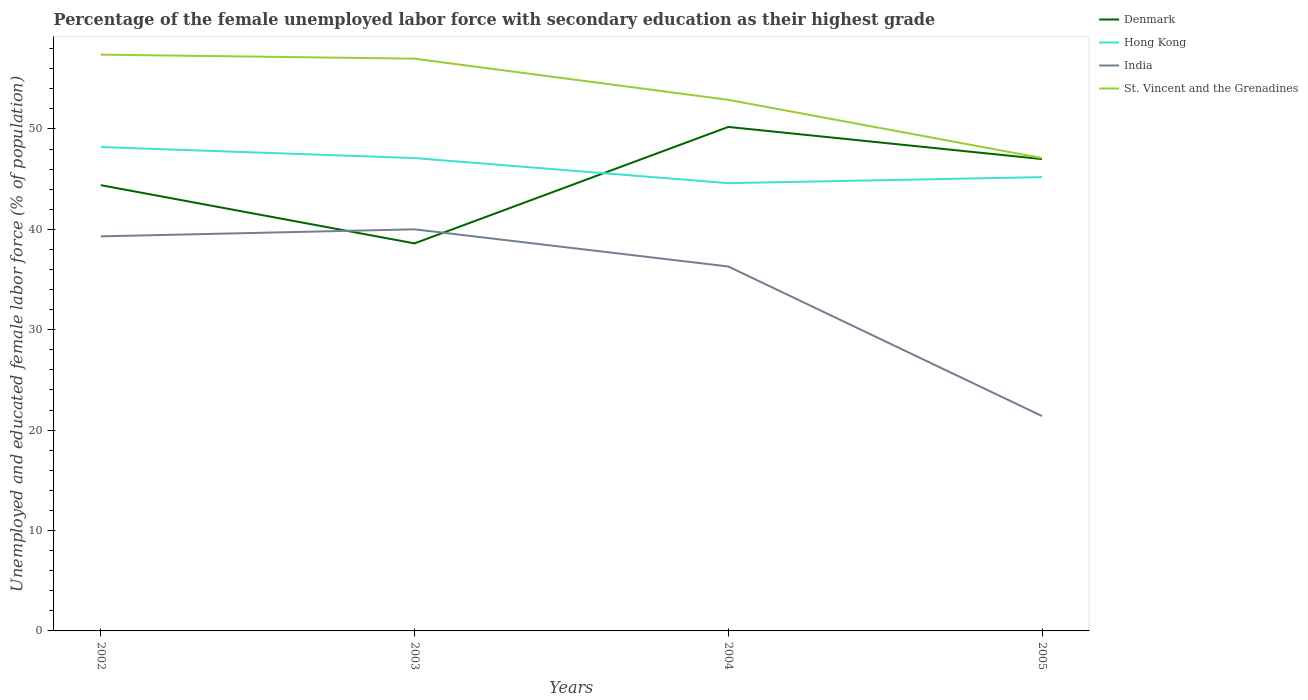Does the line corresponding to St. Vincent and the Grenadines intersect with the line corresponding to Denmark?
Your response must be concise. No. Across all years, what is the maximum percentage of the unemployed female labor force with secondary education in Hong Kong?
Give a very brief answer. 44.6. In which year was the percentage of the unemployed female labor force with secondary education in Hong Kong maximum?
Offer a terse response. 2004. What is the total percentage of the unemployed female labor force with secondary education in India in the graph?
Offer a terse response. 3.7. What is the difference between the highest and the second highest percentage of the unemployed female labor force with secondary education in St. Vincent and the Grenadines?
Offer a terse response. 10.3. What is the difference between the highest and the lowest percentage of the unemployed female labor force with secondary education in India?
Your answer should be compact. 3. How many lines are there?
Provide a succinct answer. 4. What is the difference between two consecutive major ticks on the Y-axis?
Offer a terse response. 10. Does the graph contain any zero values?
Make the answer very short. No. Does the graph contain grids?
Provide a succinct answer. No. Where does the legend appear in the graph?
Make the answer very short. Top right. How are the legend labels stacked?
Provide a succinct answer. Vertical. What is the title of the graph?
Your answer should be very brief. Percentage of the female unemployed labor force with secondary education as their highest grade. What is the label or title of the Y-axis?
Ensure brevity in your answer.  Unemployed and educated female labor force (% of population). What is the Unemployed and educated female labor force (% of population) in Denmark in 2002?
Your answer should be compact. 44.4. What is the Unemployed and educated female labor force (% of population) of Hong Kong in 2002?
Make the answer very short. 48.2. What is the Unemployed and educated female labor force (% of population) in India in 2002?
Offer a very short reply. 39.3. What is the Unemployed and educated female labor force (% of population) of St. Vincent and the Grenadines in 2002?
Keep it short and to the point. 57.4. What is the Unemployed and educated female labor force (% of population) of Denmark in 2003?
Make the answer very short. 38.6. What is the Unemployed and educated female labor force (% of population) of Hong Kong in 2003?
Offer a terse response. 47.1. What is the Unemployed and educated female labor force (% of population) of India in 2003?
Your answer should be compact. 40. What is the Unemployed and educated female labor force (% of population) of Denmark in 2004?
Make the answer very short. 50.2. What is the Unemployed and educated female labor force (% of population) in Hong Kong in 2004?
Provide a short and direct response. 44.6. What is the Unemployed and educated female labor force (% of population) of India in 2004?
Make the answer very short. 36.3. What is the Unemployed and educated female labor force (% of population) of St. Vincent and the Grenadines in 2004?
Ensure brevity in your answer.  52.9. What is the Unemployed and educated female labor force (% of population) in Denmark in 2005?
Provide a short and direct response. 47. What is the Unemployed and educated female labor force (% of population) of Hong Kong in 2005?
Provide a short and direct response. 45.2. What is the Unemployed and educated female labor force (% of population) in India in 2005?
Make the answer very short. 21.4. What is the Unemployed and educated female labor force (% of population) in St. Vincent and the Grenadines in 2005?
Offer a terse response. 47.1. Across all years, what is the maximum Unemployed and educated female labor force (% of population) of Denmark?
Give a very brief answer. 50.2. Across all years, what is the maximum Unemployed and educated female labor force (% of population) in Hong Kong?
Offer a terse response. 48.2. Across all years, what is the maximum Unemployed and educated female labor force (% of population) of St. Vincent and the Grenadines?
Provide a succinct answer. 57.4. Across all years, what is the minimum Unemployed and educated female labor force (% of population) in Denmark?
Make the answer very short. 38.6. Across all years, what is the minimum Unemployed and educated female labor force (% of population) in Hong Kong?
Provide a short and direct response. 44.6. Across all years, what is the minimum Unemployed and educated female labor force (% of population) in India?
Offer a very short reply. 21.4. Across all years, what is the minimum Unemployed and educated female labor force (% of population) in St. Vincent and the Grenadines?
Keep it short and to the point. 47.1. What is the total Unemployed and educated female labor force (% of population) in Denmark in the graph?
Provide a succinct answer. 180.2. What is the total Unemployed and educated female labor force (% of population) of Hong Kong in the graph?
Offer a terse response. 185.1. What is the total Unemployed and educated female labor force (% of population) in India in the graph?
Offer a terse response. 137. What is the total Unemployed and educated female labor force (% of population) of St. Vincent and the Grenadines in the graph?
Your answer should be compact. 214.4. What is the difference between the Unemployed and educated female labor force (% of population) in Hong Kong in 2002 and that in 2004?
Provide a short and direct response. 3.6. What is the difference between the Unemployed and educated female labor force (% of population) of St. Vincent and the Grenadines in 2002 and that in 2004?
Ensure brevity in your answer.  4.5. What is the difference between the Unemployed and educated female labor force (% of population) of Denmark in 2002 and that in 2005?
Provide a succinct answer. -2.6. What is the difference between the Unemployed and educated female labor force (% of population) of Hong Kong in 2002 and that in 2005?
Offer a terse response. 3. What is the difference between the Unemployed and educated female labor force (% of population) in St. Vincent and the Grenadines in 2002 and that in 2005?
Ensure brevity in your answer.  10.3. What is the difference between the Unemployed and educated female labor force (% of population) in Denmark in 2003 and that in 2004?
Your answer should be very brief. -11.6. What is the difference between the Unemployed and educated female labor force (% of population) in India in 2003 and that in 2004?
Offer a terse response. 3.7. What is the difference between the Unemployed and educated female labor force (% of population) in St. Vincent and the Grenadines in 2003 and that in 2005?
Offer a terse response. 9.9. What is the difference between the Unemployed and educated female labor force (% of population) in Denmark in 2004 and that in 2005?
Your answer should be compact. 3.2. What is the difference between the Unemployed and educated female labor force (% of population) of Hong Kong in 2004 and that in 2005?
Offer a very short reply. -0.6. What is the difference between the Unemployed and educated female labor force (% of population) in St. Vincent and the Grenadines in 2004 and that in 2005?
Ensure brevity in your answer.  5.8. What is the difference between the Unemployed and educated female labor force (% of population) of Denmark in 2002 and the Unemployed and educated female labor force (% of population) of Hong Kong in 2003?
Keep it short and to the point. -2.7. What is the difference between the Unemployed and educated female labor force (% of population) in Denmark in 2002 and the Unemployed and educated female labor force (% of population) in St. Vincent and the Grenadines in 2003?
Provide a short and direct response. -12.6. What is the difference between the Unemployed and educated female labor force (% of population) of Hong Kong in 2002 and the Unemployed and educated female labor force (% of population) of India in 2003?
Your response must be concise. 8.2. What is the difference between the Unemployed and educated female labor force (% of population) of India in 2002 and the Unemployed and educated female labor force (% of population) of St. Vincent and the Grenadines in 2003?
Keep it short and to the point. -17.7. What is the difference between the Unemployed and educated female labor force (% of population) in Denmark in 2002 and the Unemployed and educated female labor force (% of population) in Hong Kong in 2004?
Make the answer very short. -0.2. What is the difference between the Unemployed and educated female labor force (% of population) of Denmark in 2002 and the Unemployed and educated female labor force (% of population) of St. Vincent and the Grenadines in 2004?
Keep it short and to the point. -8.5. What is the difference between the Unemployed and educated female labor force (% of population) in Denmark in 2002 and the Unemployed and educated female labor force (% of population) in Hong Kong in 2005?
Ensure brevity in your answer.  -0.8. What is the difference between the Unemployed and educated female labor force (% of population) in Denmark in 2002 and the Unemployed and educated female labor force (% of population) in India in 2005?
Ensure brevity in your answer.  23. What is the difference between the Unemployed and educated female labor force (% of population) in Hong Kong in 2002 and the Unemployed and educated female labor force (% of population) in India in 2005?
Your answer should be very brief. 26.8. What is the difference between the Unemployed and educated female labor force (% of population) in India in 2002 and the Unemployed and educated female labor force (% of population) in St. Vincent and the Grenadines in 2005?
Keep it short and to the point. -7.8. What is the difference between the Unemployed and educated female labor force (% of population) in Denmark in 2003 and the Unemployed and educated female labor force (% of population) in India in 2004?
Your answer should be very brief. 2.3. What is the difference between the Unemployed and educated female labor force (% of population) of Denmark in 2003 and the Unemployed and educated female labor force (% of population) of St. Vincent and the Grenadines in 2004?
Your answer should be compact. -14.3. What is the difference between the Unemployed and educated female labor force (% of population) in Hong Kong in 2003 and the Unemployed and educated female labor force (% of population) in India in 2004?
Make the answer very short. 10.8. What is the difference between the Unemployed and educated female labor force (% of population) of India in 2003 and the Unemployed and educated female labor force (% of population) of St. Vincent and the Grenadines in 2004?
Your answer should be very brief. -12.9. What is the difference between the Unemployed and educated female labor force (% of population) of Denmark in 2003 and the Unemployed and educated female labor force (% of population) of Hong Kong in 2005?
Offer a terse response. -6.6. What is the difference between the Unemployed and educated female labor force (% of population) in Denmark in 2003 and the Unemployed and educated female labor force (% of population) in India in 2005?
Keep it short and to the point. 17.2. What is the difference between the Unemployed and educated female labor force (% of population) of Hong Kong in 2003 and the Unemployed and educated female labor force (% of population) of India in 2005?
Provide a short and direct response. 25.7. What is the difference between the Unemployed and educated female labor force (% of population) in Hong Kong in 2003 and the Unemployed and educated female labor force (% of population) in St. Vincent and the Grenadines in 2005?
Give a very brief answer. 0. What is the difference between the Unemployed and educated female labor force (% of population) in India in 2003 and the Unemployed and educated female labor force (% of population) in St. Vincent and the Grenadines in 2005?
Make the answer very short. -7.1. What is the difference between the Unemployed and educated female labor force (% of population) of Denmark in 2004 and the Unemployed and educated female labor force (% of population) of Hong Kong in 2005?
Ensure brevity in your answer.  5. What is the difference between the Unemployed and educated female labor force (% of population) in Denmark in 2004 and the Unemployed and educated female labor force (% of population) in India in 2005?
Make the answer very short. 28.8. What is the difference between the Unemployed and educated female labor force (% of population) of Hong Kong in 2004 and the Unemployed and educated female labor force (% of population) of India in 2005?
Ensure brevity in your answer.  23.2. What is the difference between the Unemployed and educated female labor force (% of population) in Hong Kong in 2004 and the Unemployed and educated female labor force (% of population) in St. Vincent and the Grenadines in 2005?
Ensure brevity in your answer.  -2.5. What is the average Unemployed and educated female labor force (% of population) of Denmark per year?
Make the answer very short. 45.05. What is the average Unemployed and educated female labor force (% of population) in Hong Kong per year?
Your answer should be very brief. 46.27. What is the average Unemployed and educated female labor force (% of population) in India per year?
Your response must be concise. 34.25. What is the average Unemployed and educated female labor force (% of population) in St. Vincent and the Grenadines per year?
Your answer should be very brief. 53.6. In the year 2002, what is the difference between the Unemployed and educated female labor force (% of population) of Denmark and Unemployed and educated female labor force (% of population) of Hong Kong?
Your response must be concise. -3.8. In the year 2002, what is the difference between the Unemployed and educated female labor force (% of population) of Denmark and Unemployed and educated female labor force (% of population) of India?
Your answer should be compact. 5.1. In the year 2002, what is the difference between the Unemployed and educated female labor force (% of population) in Hong Kong and Unemployed and educated female labor force (% of population) in India?
Give a very brief answer. 8.9. In the year 2002, what is the difference between the Unemployed and educated female labor force (% of population) of India and Unemployed and educated female labor force (% of population) of St. Vincent and the Grenadines?
Give a very brief answer. -18.1. In the year 2003, what is the difference between the Unemployed and educated female labor force (% of population) of Denmark and Unemployed and educated female labor force (% of population) of St. Vincent and the Grenadines?
Your response must be concise. -18.4. In the year 2003, what is the difference between the Unemployed and educated female labor force (% of population) of Hong Kong and Unemployed and educated female labor force (% of population) of India?
Offer a terse response. 7.1. In the year 2003, what is the difference between the Unemployed and educated female labor force (% of population) in India and Unemployed and educated female labor force (% of population) in St. Vincent and the Grenadines?
Ensure brevity in your answer.  -17. In the year 2004, what is the difference between the Unemployed and educated female labor force (% of population) of Hong Kong and Unemployed and educated female labor force (% of population) of St. Vincent and the Grenadines?
Provide a short and direct response. -8.3. In the year 2004, what is the difference between the Unemployed and educated female labor force (% of population) in India and Unemployed and educated female labor force (% of population) in St. Vincent and the Grenadines?
Your answer should be compact. -16.6. In the year 2005, what is the difference between the Unemployed and educated female labor force (% of population) in Denmark and Unemployed and educated female labor force (% of population) in Hong Kong?
Your answer should be very brief. 1.8. In the year 2005, what is the difference between the Unemployed and educated female labor force (% of population) in Denmark and Unemployed and educated female labor force (% of population) in India?
Provide a succinct answer. 25.6. In the year 2005, what is the difference between the Unemployed and educated female labor force (% of population) of Denmark and Unemployed and educated female labor force (% of population) of St. Vincent and the Grenadines?
Provide a succinct answer. -0.1. In the year 2005, what is the difference between the Unemployed and educated female labor force (% of population) of Hong Kong and Unemployed and educated female labor force (% of population) of India?
Your response must be concise. 23.8. In the year 2005, what is the difference between the Unemployed and educated female labor force (% of population) in India and Unemployed and educated female labor force (% of population) in St. Vincent and the Grenadines?
Offer a terse response. -25.7. What is the ratio of the Unemployed and educated female labor force (% of population) in Denmark in 2002 to that in 2003?
Offer a terse response. 1.15. What is the ratio of the Unemployed and educated female labor force (% of population) of Hong Kong in 2002 to that in 2003?
Your answer should be compact. 1.02. What is the ratio of the Unemployed and educated female labor force (% of population) of India in 2002 to that in 2003?
Your answer should be very brief. 0.98. What is the ratio of the Unemployed and educated female labor force (% of population) of Denmark in 2002 to that in 2004?
Provide a succinct answer. 0.88. What is the ratio of the Unemployed and educated female labor force (% of population) of Hong Kong in 2002 to that in 2004?
Keep it short and to the point. 1.08. What is the ratio of the Unemployed and educated female labor force (% of population) of India in 2002 to that in 2004?
Offer a very short reply. 1.08. What is the ratio of the Unemployed and educated female labor force (% of population) in St. Vincent and the Grenadines in 2002 to that in 2004?
Make the answer very short. 1.09. What is the ratio of the Unemployed and educated female labor force (% of population) of Denmark in 2002 to that in 2005?
Ensure brevity in your answer.  0.94. What is the ratio of the Unemployed and educated female labor force (% of population) in Hong Kong in 2002 to that in 2005?
Your answer should be very brief. 1.07. What is the ratio of the Unemployed and educated female labor force (% of population) of India in 2002 to that in 2005?
Keep it short and to the point. 1.84. What is the ratio of the Unemployed and educated female labor force (% of population) in St. Vincent and the Grenadines in 2002 to that in 2005?
Provide a succinct answer. 1.22. What is the ratio of the Unemployed and educated female labor force (% of population) of Denmark in 2003 to that in 2004?
Make the answer very short. 0.77. What is the ratio of the Unemployed and educated female labor force (% of population) of Hong Kong in 2003 to that in 2004?
Provide a succinct answer. 1.06. What is the ratio of the Unemployed and educated female labor force (% of population) in India in 2003 to that in 2004?
Provide a succinct answer. 1.1. What is the ratio of the Unemployed and educated female labor force (% of population) of St. Vincent and the Grenadines in 2003 to that in 2004?
Provide a succinct answer. 1.08. What is the ratio of the Unemployed and educated female labor force (% of population) in Denmark in 2003 to that in 2005?
Give a very brief answer. 0.82. What is the ratio of the Unemployed and educated female labor force (% of population) of Hong Kong in 2003 to that in 2005?
Your response must be concise. 1.04. What is the ratio of the Unemployed and educated female labor force (% of population) in India in 2003 to that in 2005?
Your response must be concise. 1.87. What is the ratio of the Unemployed and educated female labor force (% of population) of St. Vincent and the Grenadines in 2003 to that in 2005?
Give a very brief answer. 1.21. What is the ratio of the Unemployed and educated female labor force (% of population) of Denmark in 2004 to that in 2005?
Provide a short and direct response. 1.07. What is the ratio of the Unemployed and educated female labor force (% of population) in Hong Kong in 2004 to that in 2005?
Your response must be concise. 0.99. What is the ratio of the Unemployed and educated female labor force (% of population) in India in 2004 to that in 2005?
Offer a very short reply. 1.7. What is the ratio of the Unemployed and educated female labor force (% of population) in St. Vincent and the Grenadines in 2004 to that in 2005?
Keep it short and to the point. 1.12. What is the difference between the highest and the second highest Unemployed and educated female labor force (% of population) in Denmark?
Keep it short and to the point. 3.2. What is the difference between the highest and the second highest Unemployed and educated female labor force (% of population) of Hong Kong?
Provide a succinct answer. 1.1. What is the difference between the highest and the second highest Unemployed and educated female labor force (% of population) of India?
Offer a terse response. 0.7. What is the difference between the highest and the second highest Unemployed and educated female labor force (% of population) of St. Vincent and the Grenadines?
Make the answer very short. 0.4. What is the difference between the highest and the lowest Unemployed and educated female labor force (% of population) in Denmark?
Ensure brevity in your answer.  11.6. What is the difference between the highest and the lowest Unemployed and educated female labor force (% of population) in Hong Kong?
Your answer should be compact. 3.6. What is the difference between the highest and the lowest Unemployed and educated female labor force (% of population) in India?
Ensure brevity in your answer.  18.6. What is the difference between the highest and the lowest Unemployed and educated female labor force (% of population) of St. Vincent and the Grenadines?
Provide a short and direct response. 10.3. 